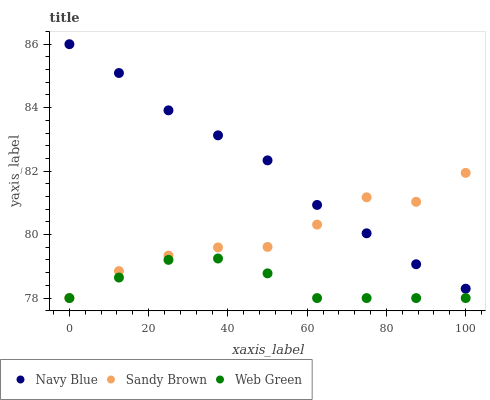Does Web Green have the minimum area under the curve?
Answer yes or no. Yes. Does Navy Blue have the maximum area under the curve?
Answer yes or no. Yes. Does Sandy Brown have the minimum area under the curve?
Answer yes or no. No. Does Sandy Brown have the maximum area under the curve?
Answer yes or no. No. Is Navy Blue the smoothest?
Answer yes or no. Yes. Is Sandy Brown the roughest?
Answer yes or no. Yes. Is Web Green the smoothest?
Answer yes or no. No. Is Web Green the roughest?
Answer yes or no. No. Does Sandy Brown have the lowest value?
Answer yes or no. Yes. Does Navy Blue have the highest value?
Answer yes or no. Yes. Does Sandy Brown have the highest value?
Answer yes or no. No. Is Web Green less than Navy Blue?
Answer yes or no. Yes. Is Navy Blue greater than Web Green?
Answer yes or no. Yes. Does Sandy Brown intersect Navy Blue?
Answer yes or no. Yes. Is Sandy Brown less than Navy Blue?
Answer yes or no. No. Is Sandy Brown greater than Navy Blue?
Answer yes or no. No. Does Web Green intersect Navy Blue?
Answer yes or no. No. 